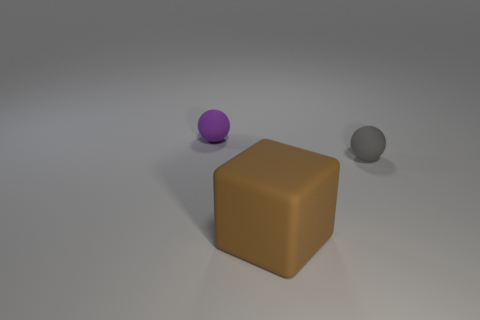What number of other things are there of the same material as the brown object
Make the answer very short. 2. Is the number of small rubber balls in front of the purple rubber sphere greater than the number of purple rubber spheres in front of the gray object?
Give a very brief answer. Yes. There is a purple ball; how many purple objects are right of it?
Give a very brief answer. 0. Does the brown object have the same material as the thing that is to the right of the brown thing?
Provide a short and direct response. Yes. Are there any other things that are the same shape as the brown thing?
Keep it short and to the point. No. Is the brown object made of the same material as the small gray object?
Offer a terse response. Yes. There is a small thing in front of the purple ball; is there a tiny purple rubber sphere in front of it?
Ensure brevity in your answer.  No. How many matte things are both on the left side of the gray sphere and behind the large matte thing?
Keep it short and to the point. 1. The large brown rubber thing to the left of the gray object has what shape?
Give a very brief answer. Cube. What number of gray spheres have the same size as the purple rubber ball?
Your answer should be compact. 1. 